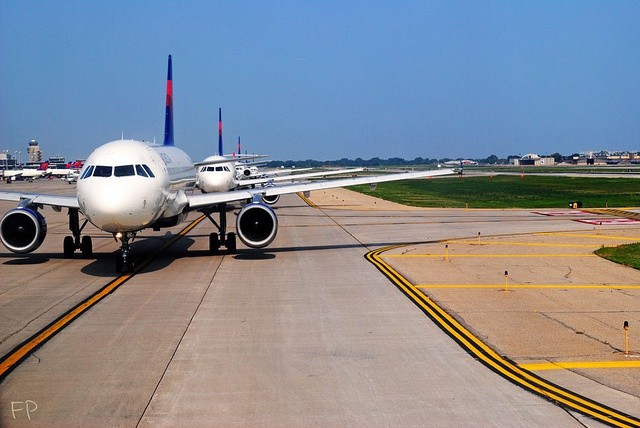Describe the objects in this image and their specific colors. I can see airplane in gray, white, black, and darkgray tones, airplane in gray, white, darkgray, and black tones, airplane in gray, white, darkgray, and navy tones, airplane in gray, lightgray, and darkgray tones, and airplane in gray and darkgray tones in this image. 